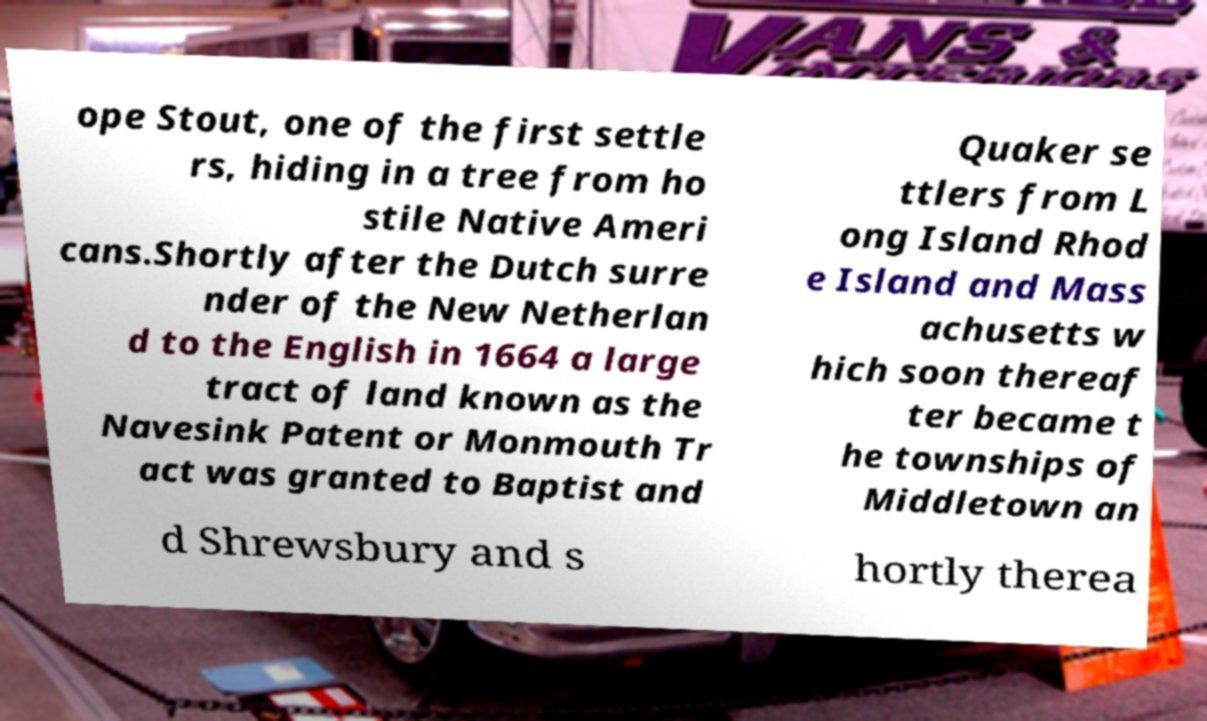Could you assist in decoding the text presented in this image and type it out clearly? ope Stout, one of the first settle rs, hiding in a tree from ho stile Native Ameri cans.Shortly after the Dutch surre nder of the New Netherlan d to the English in 1664 a large tract of land known as the Navesink Patent or Monmouth Tr act was granted to Baptist and Quaker se ttlers from L ong Island Rhod e Island and Mass achusetts w hich soon thereaf ter became t he townships of Middletown an d Shrewsbury and s hortly therea 